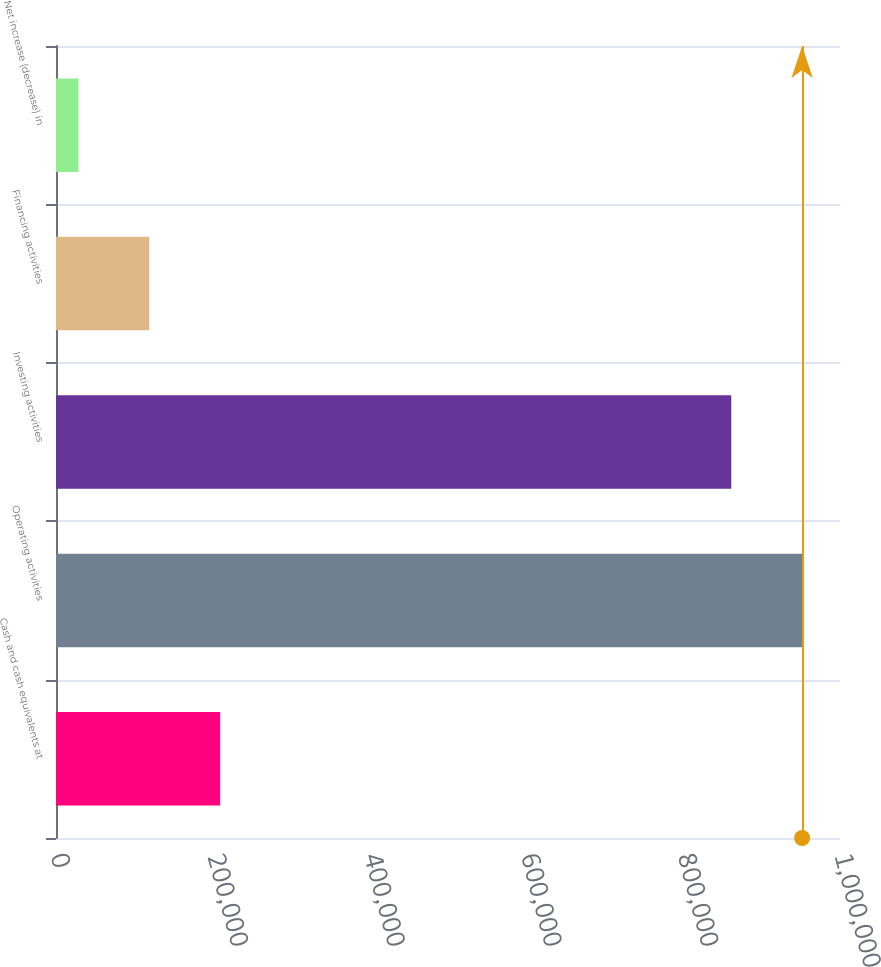Convert chart to OTSL. <chart><loc_0><loc_0><loc_500><loc_500><bar_chart><fcel>Cash and cash equivalents at<fcel>Operating activities<fcel>Investing activities<fcel>Financing activities<fcel>Net increase (decrease) in<nl><fcel>209343<fcel>951703<fcel>861329<fcel>118969<fcel>28595<nl></chart> 